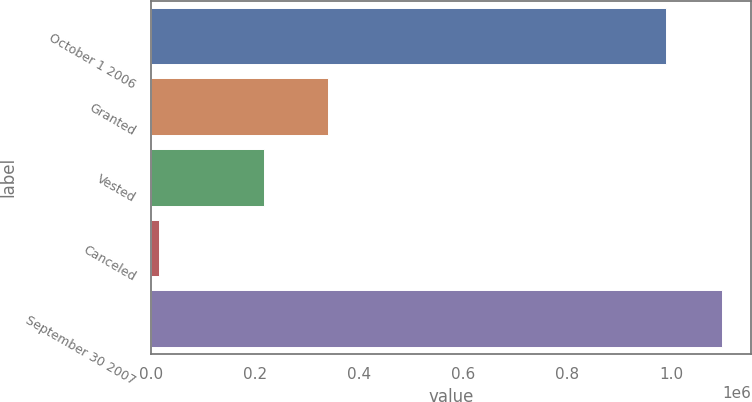Convert chart. <chart><loc_0><loc_0><loc_500><loc_500><bar_chart><fcel>October 1 2006<fcel>Granted<fcel>Vested<fcel>Canceled<fcel>September 30 2007<nl><fcel>989946<fcel>339969<fcel>217145<fcel>16989<fcel>1.09783e+06<nl></chart> 